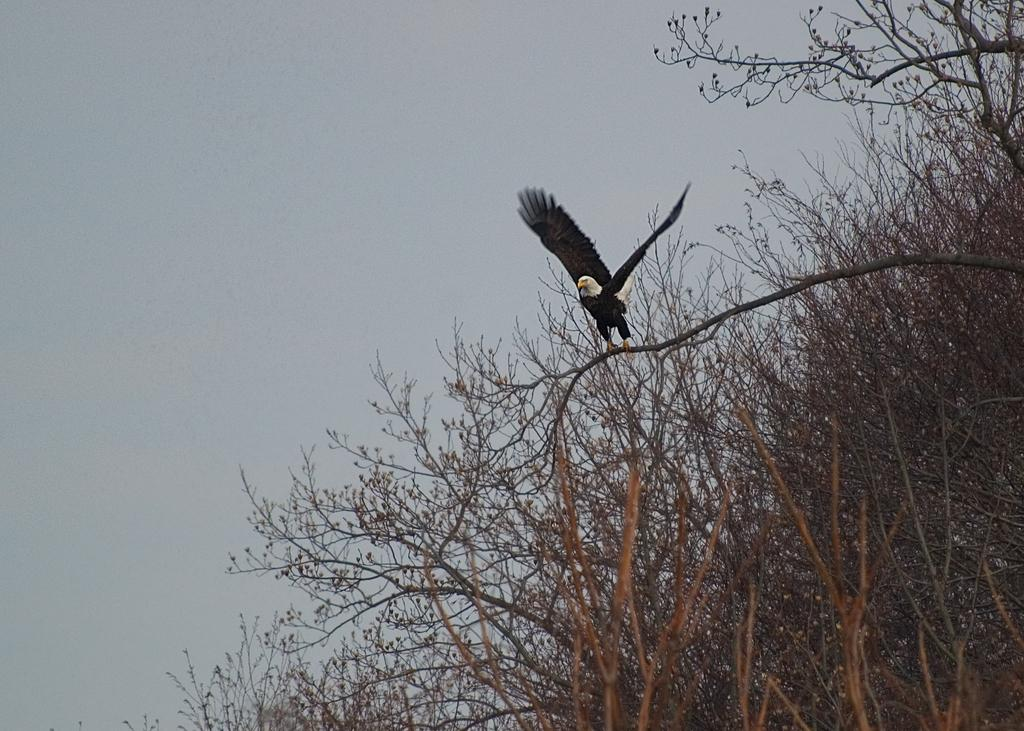Where was the picture taken? The picture was clicked outside. What animal is the main subject of the image? There is a black color eagle in the image. What is the eagle doing in the image? The eagle appears to be flying. What type of vegetation can be seen in the image? There are trees visible in the image. What part of the natural environment is visible in the image? The sky is visible in the image. What month is it in the image? The month cannot be determined from the image, as there is no information about the time of year. Can you see a ladybug in the image? There is no ladybug present in the image. 